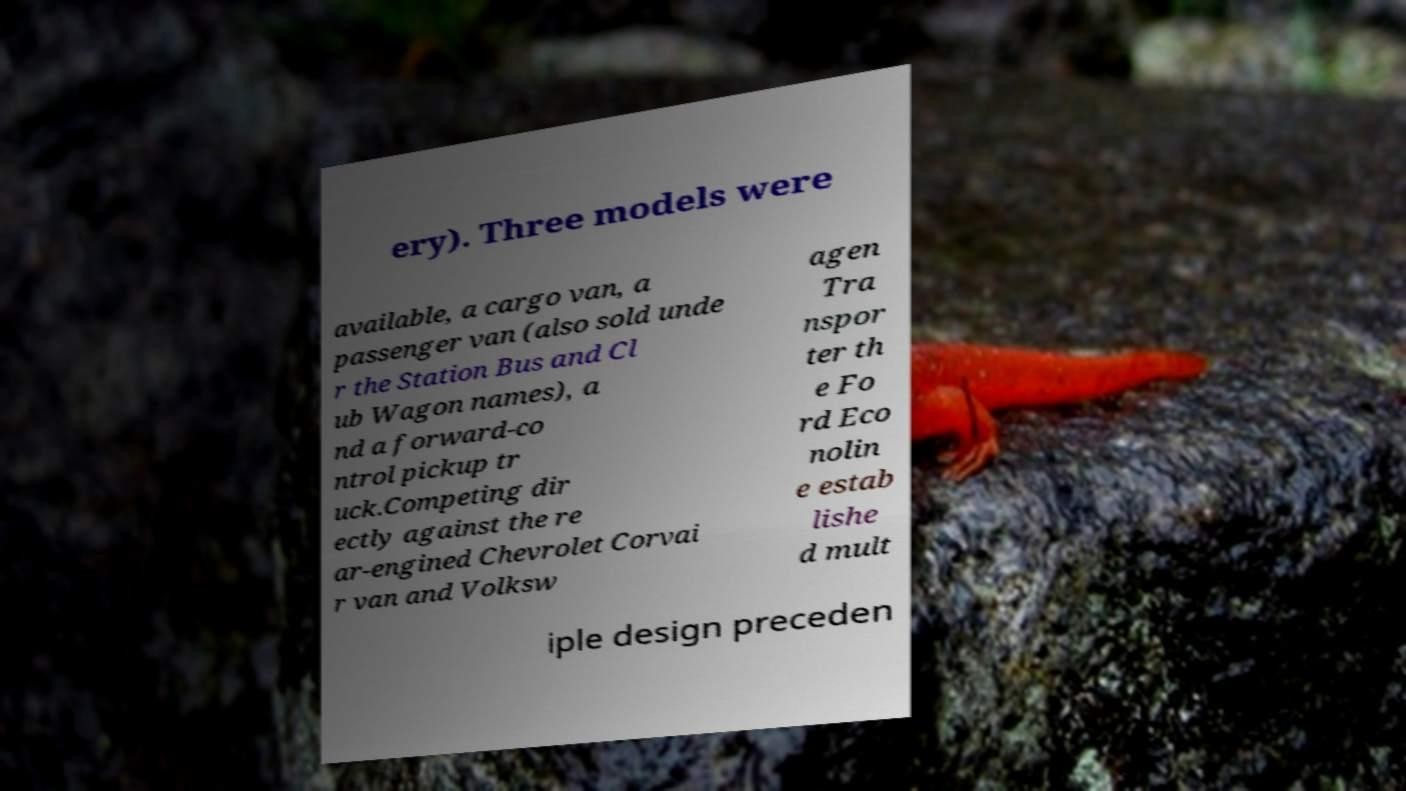Could you assist in decoding the text presented in this image and type it out clearly? ery). Three models were available, a cargo van, a passenger van (also sold unde r the Station Bus and Cl ub Wagon names), a nd a forward-co ntrol pickup tr uck.Competing dir ectly against the re ar-engined Chevrolet Corvai r van and Volksw agen Tra nspor ter th e Fo rd Eco nolin e estab lishe d mult iple design preceden 